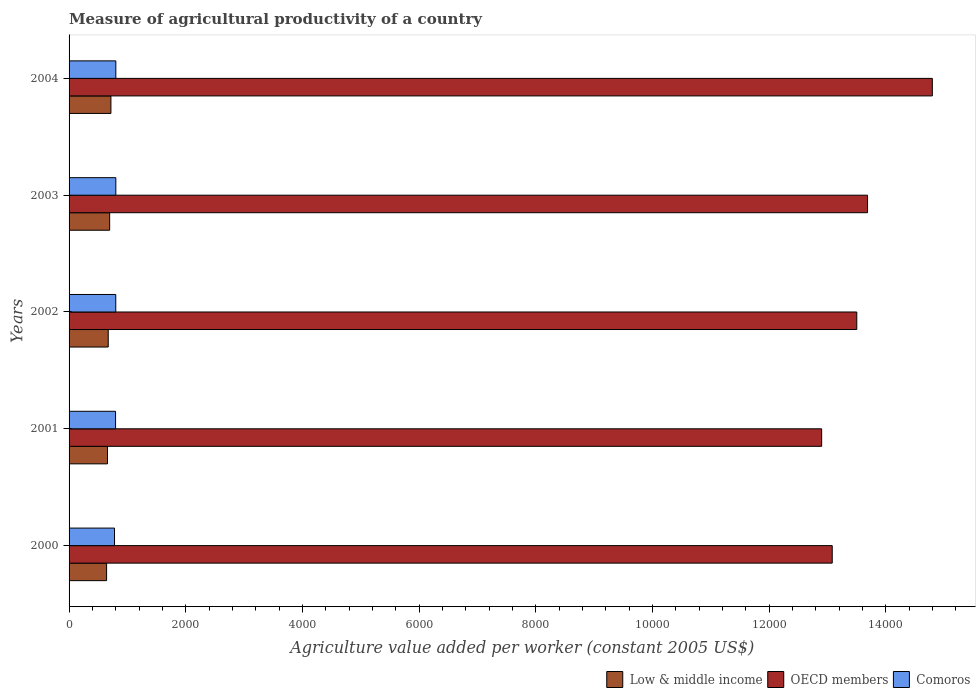How many different coloured bars are there?
Provide a succinct answer. 3. How many groups of bars are there?
Provide a short and direct response. 5. Are the number of bars on each tick of the Y-axis equal?
Keep it short and to the point. Yes. How many bars are there on the 4th tick from the bottom?
Your answer should be very brief. 3. In how many cases, is the number of bars for a given year not equal to the number of legend labels?
Ensure brevity in your answer.  0. What is the measure of agricultural productivity in Low & middle income in 2001?
Provide a short and direct response. 658.75. Across all years, what is the maximum measure of agricultural productivity in Low & middle income?
Offer a terse response. 717.21. Across all years, what is the minimum measure of agricultural productivity in Low & middle income?
Your answer should be very brief. 643.04. What is the total measure of agricultural productivity in Low & middle income in the graph?
Provide a succinct answer. 3385.64. What is the difference between the measure of agricultural productivity in OECD members in 2001 and that in 2004?
Ensure brevity in your answer.  -1896.73. What is the difference between the measure of agricultural productivity in OECD members in 2004 and the measure of agricultural productivity in Low & middle income in 2003?
Provide a short and direct response. 1.41e+04. What is the average measure of agricultural productivity in OECD members per year?
Your answer should be very brief. 1.36e+04. In the year 2000, what is the difference between the measure of agricultural productivity in Low & middle income and measure of agricultural productivity in Comoros?
Provide a short and direct response. -135.79. What is the ratio of the measure of agricultural productivity in Comoros in 2002 to that in 2004?
Provide a short and direct response. 1. Is the difference between the measure of agricultural productivity in Low & middle income in 2000 and 2002 greater than the difference between the measure of agricultural productivity in Comoros in 2000 and 2002?
Your response must be concise. No. What is the difference between the highest and the second highest measure of agricultural productivity in OECD members?
Your answer should be very brief. 1110.25. What is the difference between the highest and the lowest measure of agricultural productivity in Low & middle income?
Your answer should be compact. 74.17. Is the sum of the measure of agricultural productivity in Low & middle income in 2000 and 2004 greater than the maximum measure of agricultural productivity in OECD members across all years?
Your answer should be very brief. No. What does the 1st bar from the top in 2004 represents?
Keep it short and to the point. Comoros. How many bars are there?
Keep it short and to the point. 15. What is the difference between two consecutive major ticks on the X-axis?
Make the answer very short. 2000. Where does the legend appear in the graph?
Offer a terse response. Bottom right. How many legend labels are there?
Your answer should be very brief. 3. How are the legend labels stacked?
Give a very brief answer. Horizontal. What is the title of the graph?
Make the answer very short. Measure of agricultural productivity of a country. Does "Monaco" appear as one of the legend labels in the graph?
Provide a short and direct response. No. What is the label or title of the X-axis?
Your answer should be compact. Agriculture value added per worker (constant 2005 US$). What is the label or title of the Y-axis?
Your response must be concise. Years. What is the Agriculture value added per worker (constant 2005 US$) of Low & middle income in 2000?
Give a very brief answer. 643.04. What is the Agriculture value added per worker (constant 2005 US$) of OECD members in 2000?
Give a very brief answer. 1.31e+04. What is the Agriculture value added per worker (constant 2005 US$) of Comoros in 2000?
Your response must be concise. 778.83. What is the Agriculture value added per worker (constant 2005 US$) in Low & middle income in 2001?
Provide a succinct answer. 658.75. What is the Agriculture value added per worker (constant 2005 US$) of OECD members in 2001?
Your response must be concise. 1.29e+04. What is the Agriculture value added per worker (constant 2005 US$) in Comoros in 2001?
Make the answer very short. 796.84. What is the Agriculture value added per worker (constant 2005 US$) in Low & middle income in 2002?
Keep it short and to the point. 671.12. What is the Agriculture value added per worker (constant 2005 US$) of OECD members in 2002?
Give a very brief answer. 1.35e+04. What is the Agriculture value added per worker (constant 2005 US$) in Comoros in 2002?
Your response must be concise. 800.25. What is the Agriculture value added per worker (constant 2005 US$) of Low & middle income in 2003?
Give a very brief answer. 695.52. What is the Agriculture value added per worker (constant 2005 US$) in OECD members in 2003?
Offer a very short reply. 1.37e+04. What is the Agriculture value added per worker (constant 2005 US$) of Comoros in 2003?
Provide a succinct answer. 801.28. What is the Agriculture value added per worker (constant 2005 US$) in Low & middle income in 2004?
Your answer should be very brief. 717.21. What is the Agriculture value added per worker (constant 2005 US$) of OECD members in 2004?
Offer a very short reply. 1.48e+04. What is the Agriculture value added per worker (constant 2005 US$) of Comoros in 2004?
Ensure brevity in your answer.  801.26. Across all years, what is the maximum Agriculture value added per worker (constant 2005 US$) in Low & middle income?
Provide a short and direct response. 717.21. Across all years, what is the maximum Agriculture value added per worker (constant 2005 US$) in OECD members?
Your response must be concise. 1.48e+04. Across all years, what is the maximum Agriculture value added per worker (constant 2005 US$) in Comoros?
Offer a terse response. 801.28. Across all years, what is the minimum Agriculture value added per worker (constant 2005 US$) of Low & middle income?
Your answer should be very brief. 643.04. Across all years, what is the minimum Agriculture value added per worker (constant 2005 US$) of OECD members?
Your answer should be compact. 1.29e+04. Across all years, what is the minimum Agriculture value added per worker (constant 2005 US$) of Comoros?
Keep it short and to the point. 778.83. What is the total Agriculture value added per worker (constant 2005 US$) of Low & middle income in the graph?
Offer a very short reply. 3385.64. What is the total Agriculture value added per worker (constant 2005 US$) of OECD members in the graph?
Offer a very short reply. 6.80e+04. What is the total Agriculture value added per worker (constant 2005 US$) of Comoros in the graph?
Offer a very short reply. 3978.47. What is the difference between the Agriculture value added per worker (constant 2005 US$) in Low & middle income in 2000 and that in 2001?
Provide a short and direct response. -15.71. What is the difference between the Agriculture value added per worker (constant 2005 US$) in OECD members in 2000 and that in 2001?
Offer a terse response. 181.16. What is the difference between the Agriculture value added per worker (constant 2005 US$) of Comoros in 2000 and that in 2001?
Ensure brevity in your answer.  -18.01. What is the difference between the Agriculture value added per worker (constant 2005 US$) of Low & middle income in 2000 and that in 2002?
Keep it short and to the point. -28.08. What is the difference between the Agriculture value added per worker (constant 2005 US$) of OECD members in 2000 and that in 2002?
Your answer should be very brief. -420.72. What is the difference between the Agriculture value added per worker (constant 2005 US$) of Comoros in 2000 and that in 2002?
Your answer should be compact. -21.42. What is the difference between the Agriculture value added per worker (constant 2005 US$) in Low & middle income in 2000 and that in 2003?
Your answer should be very brief. -52.48. What is the difference between the Agriculture value added per worker (constant 2005 US$) of OECD members in 2000 and that in 2003?
Your response must be concise. -605.32. What is the difference between the Agriculture value added per worker (constant 2005 US$) of Comoros in 2000 and that in 2003?
Provide a short and direct response. -22.45. What is the difference between the Agriculture value added per worker (constant 2005 US$) in Low & middle income in 2000 and that in 2004?
Your answer should be very brief. -74.17. What is the difference between the Agriculture value added per worker (constant 2005 US$) in OECD members in 2000 and that in 2004?
Provide a short and direct response. -1715.56. What is the difference between the Agriculture value added per worker (constant 2005 US$) of Comoros in 2000 and that in 2004?
Provide a short and direct response. -22.43. What is the difference between the Agriculture value added per worker (constant 2005 US$) of Low & middle income in 2001 and that in 2002?
Your answer should be compact. -12.37. What is the difference between the Agriculture value added per worker (constant 2005 US$) in OECD members in 2001 and that in 2002?
Your answer should be very brief. -601.88. What is the difference between the Agriculture value added per worker (constant 2005 US$) in Comoros in 2001 and that in 2002?
Offer a very short reply. -3.41. What is the difference between the Agriculture value added per worker (constant 2005 US$) in Low & middle income in 2001 and that in 2003?
Provide a succinct answer. -36.77. What is the difference between the Agriculture value added per worker (constant 2005 US$) of OECD members in 2001 and that in 2003?
Provide a short and direct response. -786.48. What is the difference between the Agriculture value added per worker (constant 2005 US$) in Comoros in 2001 and that in 2003?
Your response must be concise. -4.44. What is the difference between the Agriculture value added per worker (constant 2005 US$) in Low & middle income in 2001 and that in 2004?
Give a very brief answer. -58.46. What is the difference between the Agriculture value added per worker (constant 2005 US$) of OECD members in 2001 and that in 2004?
Offer a very short reply. -1896.73. What is the difference between the Agriculture value added per worker (constant 2005 US$) of Comoros in 2001 and that in 2004?
Offer a very short reply. -4.42. What is the difference between the Agriculture value added per worker (constant 2005 US$) of Low & middle income in 2002 and that in 2003?
Keep it short and to the point. -24.4. What is the difference between the Agriculture value added per worker (constant 2005 US$) in OECD members in 2002 and that in 2003?
Offer a very short reply. -184.6. What is the difference between the Agriculture value added per worker (constant 2005 US$) of Comoros in 2002 and that in 2003?
Make the answer very short. -1.02. What is the difference between the Agriculture value added per worker (constant 2005 US$) in Low & middle income in 2002 and that in 2004?
Provide a short and direct response. -46.09. What is the difference between the Agriculture value added per worker (constant 2005 US$) of OECD members in 2002 and that in 2004?
Ensure brevity in your answer.  -1294.85. What is the difference between the Agriculture value added per worker (constant 2005 US$) of Comoros in 2002 and that in 2004?
Make the answer very short. -1.01. What is the difference between the Agriculture value added per worker (constant 2005 US$) of Low & middle income in 2003 and that in 2004?
Your response must be concise. -21.69. What is the difference between the Agriculture value added per worker (constant 2005 US$) of OECD members in 2003 and that in 2004?
Your answer should be very brief. -1110.25. What is the difference between the Agriculture value added per worker (constant 2005 US$) in Comoros in 2003 and that in 2004?
Keep it short and to the point. 0.02. What is the difference between the Agriculture value added per worker (constant 2005 US$) of Low & middle income in 2000 and the Agriculture value added per worker (constant 2005 US$) of OECD members in 2001?
Your response must be concise. -1.23e+04. What is the difference between the Agriculture value added per worker (constant 2005 US$) of Low & middle income in 2000 and the Agriculture value added per worker (constant 2005 US$) of Comoros in 2001?
Make the answer very short. -153.81. What is the difference between the Agriculture value added per worker (constant 2005 US$) in OECD members in 2000 and the Agriculture value added per worker (constant 2005 US$) in Comoros in 2001?
Provide a short and direct response. 1.23e+04. What is the difference between the Agriculture value added per worker (constant 2005 US$) in Low & middle income in 2000 and the Agriculture value added per worker (constant 2005 US$) in OECD members in 2002?
Provide a succinct answer. -1.29e+04. What is the difference between the Agriculture value added per worker (constant 2005 US$) of Low & middle income in 2000 and the Agriculture value added per worker (constant 2005 US$) of Comoros in 2002?
Provide a short and direct response. -157.22. What is the difference between the Agriculture value added per worker (constant 2005 US$) of OECD members in 2000 and the Agriculture value added per worker (constant 2005 US$) of Comoros in 2002?
Your answer should be compact. 1.23e+04. What is the difference between the Agriculture value added per worker (constant 2005 US$) of Low & middle income in 2000 and the Agriculture value added per worker (constant 2005 US$) of OECD members in 2003?
Keep it short and to the point. -1.30e+04. What is the difference between the Agriculture value added per worker (constant 2005 US$) of Low & middle income in 2000 and the Agriculture value added per worker (constant 2005 US$) of Comoros in 2003?
Provide a succinct answer. -158.24. What is the difference between the Agriculture value added per worker (constant 2005 US$) in OECD members in 2000 and the Agriculture value added per worker (constant 2005 US$) in Comoros in 2003?
Offer a terse response. 1.23e+04. What is the difference between the Agriculture value added per worker (constant 2005 US$) in Low & middle income in 2000 and the Agriculture value added per worker (constant 2005 US$) in OECD members in 2004?
Ensure brevity in your answer.  -1.42e+04. What is the difference between the Agriculture value added per worker (constant 2005 US$) of Low & middle income in 2000 and the Agriculture value added per worker (constant 2005 US$) of Comoros in 2004?
Ensure brevity in your answer.  -158.23. What is the difference between the Agriculture value added per worker (constant 2005 US$) of OECD members in 2000 and the Agriculture value added per worker (constant 2005 US$) of Comoros in 2004?
Your answer should be very brief. 1.23e+04. What is the difference between the Agriculture value added per worker (constant 2005 US$) in Low & middle income in 2001 and the Agriculture value added per worker (constant 2005 US$) in OECD members in 2002?
Keep it short and to the point. -1.28e+04. What is the difference between the Agriculture value added per worker (constant 2005 US$) in Low & middle income in 2001 and the Agriculture value added per worker (constant 2005 US$) in Comoros in 2002?
Offer a terse response. -141.5. What is the difference between the Agriculture value added per worker (constant 2005 US$) in OECD members in 2001 and the Agriculture value added per worker (constant 2005 US$) in Comoros in 2002?
Your answer should be very brief. 1.21e+04. What is the difference between the Agriculture value added per worker (constant 2005 US$) in Low & middle income in 2001 and the Agriculture value added per worker (constant 2005 US$) in OECD members in 2003?
Keep it short and to the point. -1.30e+04. What is the difference between the Agriculture value added per worker (constant 2005 US$) of Low & middle income in 2001 and the Agriculture value added per worker (constant 2005 US$) of Comoros in 2003?
Give a very brief answer. -142.53. What is the difference between the Agriculture value added per worker (constant 2005 US$) of OECD members in 2001 and the Agriculture value added per worker (constant 2005 US$) of Comoros in 2003?
Provide a succinct answer. 1.21e+04. What is the difference between the Agriculture value added per worker (constant 2005 US$) of Low & middle income in 2001 and the Agriculture value added per worker (constant 2005 US$) of OECD members in 2004?
Make the answer very short. -1.41e+04. What is the difference between the Agriculture value added per worker (constant 2005 US$) of Low & middle income in 2001 and the Agriculture value added per worker (constant 2005 US$) of Comoros in 2004?
Provide a short and direct response. -142.51. What is the difference between the Agriculture value added per worker (constant 2005 US$) in OECD members in 2001 and the Agriculture value added per worker (constant 2005 US$) in Comoros in 2004?
Provide a short and direct response. 1.21e+04. What is the difference between the Agriculture value added per worker (constant 2005 US$) of Low & middle income in 2002 and the Agriculture value added per worker (constant 2005 US$) of OECD members in 2003?
Provide a short and direct response. -1.30e+04. What is the difference between the Agriculture value added per worker (constant 2005 US$) in Low & middle income in 2002 and the Agriculture value added per worker (constant 2005 US$) in Comoros in 2003?
Provide a succinct answer. -130.16. What is the difference between the Agriculture value added per worker (constant 2005 US$) in OECD members in 2002 and the Agriculture value added per worker (constant 2005 US$) in Comoros in 2003?
Provide a short and direct response. 1.27e+04. What is the difference between the Agriculture value added per worker (constant 2005 US$) of Low & middle income in 2002 and the Agriculture value added per worker (constant 2005 US$) of OECD members in 2004?
Keep it short and to the point. -1.41e+04. What is the difference between the Agriculture value added per worker (constant 2005 US$) of Low & middle income in 2002 and the Agriculture value added per worker (constant 2005 US$) of Comoros in 2004?
Make the answer very short. -130.14. What is the difference between the Agriculture value added per worker (constant 2005 US$) in OECD members in 2002 and the Agriculture value added per worker (constant 2005 US$) in Comoros in 2004?
Provide a short and direct response. 1.27e+04. What is the difference between the Agriculture value added per worker (constant 2005 US$) in Low & middle income in 2003 and the Agriculture value added per worker (constant 2005 US$) in OECD members in 2004?
Ensure brevity in your answer.  -1.41e+04. What is the difference between the Agriculture value added per worker (constant 2005 US$) of Low & middle income in 2003 and the Agriculture value added per worker (constant 2005 US$) of Comoros in 2004?
Ensure brevity in your answer.  -105.74. What is the difference between the Agriculture value added per worker (constant 2005 US$) of OECD members in 2003 and the Agriculture value added per worker (constant 2005 US$) of Comoros in 2004?
Make the answer very short. 1.29e+04. What is the average Agriculture value added per worker (constant 2005 US$) in Low & middle income per year?
Provide a succinct answer. 677.13. What is the average Agriculture value added per worker (constant 2005 US$) in OECD members per year?
Provide a succinct answer. 1.36e+04. What is the average Agriculture value added per worker (constant 2005 US$) in Comoros per year?
Your response must be concise. 795.69. In the year 2000, what is the difference between the Agriculture value added per worker (constant 2005 US$) in Low & middle income and Agriculture value added per worker (constant 2005 US$) in OECD members?
Your answer should be very brief. -1.24e+04. In the year 2000, what is the difference between the Agriculture value added per worker (constant 2005 US$) of Low & middle income and Agriculture value added per worker (constant 2005 US$) of Comoros?
Provide a succinct answer. -135.79. In the year 2000, what is the difference between the Agriculture value added per worker (constant 2005 US$) in OECD members and Agriculture value added per worker (constant 2005 US$) in Comoros?
Provide a short and direct response. 1.23e+04. In the year 2001, what is the difference between the Agriculture value added per worker (constant 2005 US$) of Low & middle income and Agriculture value added per worker (constant 2005 US$) of OECD members?
Ensure brevity in your answer.  -1.22e+04. In the year 2001, what is the difference between the Agriculture value added per worker (constant 2005 US$) of Low & middle income and Agriculture value added per worker (constant 2005 US$) of Comoros?
Give a very brief answer. -138.09. In the year 2001, what is the difference between the Agriculture value added per worker (constant 2005 US$) of OECD members and Agriculture value added per worker (constant 2005 US$) of Comoros?
Your answer should be compact. 1.21e+04. In the year 2002, what is the difference between the Agriculture value added per worker (constant 2005 US$) of Low & middle income and Agriculture value added per worker (constant 2005 US$) of OECD members?
Your answer should be very brief. -1.28e+04. In the year 2002, what is the difference between the Agriculture value added per worker (constant 2005 US$) in Low & middle income and Agriculture value added per worker (constant 2005 US$) in Comoros?
Offer a terse response. -129.13. In the year 2002, what is the difference between the Agriculture value added per worker (constant 2005 US$) of OECD members and Agriculture value added per worker (constant 2005 US$) of Comoros?
Offer a terse response. 1.27e+04. In the year 2003, what is the difference between the Agriculture value added per worker (constant 2005 US$) of Low & middle income and Agriculture value added per worker (constant 2005 US$) of OECD members?
Provide a short and direct response. -1.30e+04. In the year 2003, what is the difference between the Agriculture value added per worker (constant 2005 US$) in Low & middle income and Agriculture value added per worker (constant 2005 US$) in Comoros?
Give a very brief answer. -105.76. In the year 2003, what is the difference between the Agriculture value added per worker (constant 2005 US$) of OECD members and Agriculture value added per worker (constant 2005 US$) of Comoros?
Keep it short and to the point. 1.29e+04. In the year 2004, what is the difference between the Agriculture value added per worker (constant 2005 US$) in Low & middle income and Agriculture value added per worker (constant 2005 US$) in OECD members?
Make the answer very short. -1.41e+04. In the year 2004, what is the difference between the Agriculture value added per worker (constant 2005 US$) in Low & middle income and Agriculture value added per worker (constant 2005 US$) in Comoros?
Make the answer very short. -84.05. In the year 2004, what is the difference between the Agriculture value added per worker (constant 2005 US$) of OECD members and Agriculture value added per worker (constant 2005 US$) of Comoros?
Offer a terse response. 1.40e+04. What is the ratio of the Agriculture value added per worker (constant 2005 US$) in Low & middle income in 2000 to that in 2001?
Provide a short and direct response. 0.98. What is the ratio of the Agriculture value added per worker (constant 2005 US$) in OECD members in 2000 to that in 2001?
Provide a short and direct response. 1.01. What is the ratio of the Agriculture value added per worker (constant 2005 US$) in Comoros in 2000 to that in 2001?
Your response must be concise. 0.98. What is the ratio of the Agriculture value added per worker (constant 2005 US$) of Low & middle income in 2000 to that in 2002?
Ensure brevity in your answer.  0.96. What is the ratio of the Agriculture value added per worker (constant 2005 US$) of OECD members in 2000 to that in 2002?
Give a very brief answer. 0.97. What is the ratio of the Agriculture value added per worker (constant 2005 US$) of Comoros in 2000 to that in 2002?
Make the answer very short. 0.97. What is the ratio of the Agriculture value added per worker (constant 2005 US$) of Low & middle income in 2000 to that in 2003?
Your answer should be very brief. 0.92. What is the ratio of the Agriculture value added per worker (constant 2005 US$) in OECD members in 2000 to that in 2003?
Give a very brief answer. 0.96. What is the ratio of the Agriculture value added per worker (constant 2005 US$) in Low & middle income in 2000 to that in 2004?
Give a very brief answer. 0.9. What is the ratio of the Agriculture value added per worker (constant 2005 US$) in OECD members in 2000 to that in 2004?
Offer a very short reply. 0.88. What is the ratio of the Agriculture value added per worker (constant 2005 US$) of Low & middle income in 2001 to that in 2002?
Provide a succinct answer. 0.98. What is the ratio of the Agriculture value added per worker (constant 2005 US$) in OECD members in 2001 to that in 2002?
Keep it short and to the point. 0.96. What is the ratio of the Agriculture value added per worker (constant 2005 US$) of Comoros in 2001 to that in 2002?
Keep it short and to the point. 1. What is the ratio of the Agriculture value added per worker (constant 2005 US$) of Low & middle income in 2001 to that in 2003?
Provide a succinct answer. 0.95. What is the ratio of the Agriculture value added per worker (constant 2005 US$) of OECD members in 2001 to that in 2003?
Keep it short and to the point. 0.94. What is the ratio of the Agriculture value added per worker (constant 2005 US$) of Comoros in 2001 to that in 2003?
Offer a very short reply. 0.99. What is the ratio of the Agriculture value added per worker (constant 2005 US$) of Low & middle income in 2001 to that in 2004?
Your response must be concise. 0.92. What is the ratio of the Agriculture value added per worker (constant 2005 US$) in OECD members in 2001 to that in 2004?
Make the answer very short. 0.87. What is the ratio of the Agriculture value added per worker (constant 2005 US$) of Comoros in 2001 to that in 2004?
Your answer should be compact. 0.99. What is the ratio of the Agriculture value added per worker (constant 2005 US$) of Low & middle income in 2002 to that in 2003?
Your answer should be compact. 0.96. What is the ratio of the Agriculture value added per worker (constant 2005 US$) of OECD members in 2002 to that in 2003?
Your answer should be very brief. 0.99. What is the ratio of the Agriculture value added per worker (constant 2005 US$) of Comoros in 2002 to that in 2003?
Offer a terse response. 1. What is the ratio of the Agriculture value added per worker (constant 2005 US$) in Low & middle income in 2002 to that in 2004?
Your answer should be very brief. 0.94. What is the ratio of the Agriculture value added per worker (constant 2005 US$) in OECD members in 2002 to that in 2004?
Ensure brevity in your answer.  0.91. What is the ratio of the Agriculture value added per worker (constant 2005 US$) in Comoros in 2002 to that in 2004?
Your response must be concise. 1. What is the ratio of the Agriculture value added per worker (constant 2005 US$) in Low & middle income in 2003 to that in 2004?
Keep it short and to the point. 0.97. What is the ratio of the Agriculture value added per worker (constant 2005 US$) of OECD members in 2003 to that in 2004?
Ensure brevity in your answer.  0.93. What is the ratio of the Agriculture value added per worker (constant 2005 US$) of Comoros in 2003 to that in 2004?
Ensure brevity in your answer.  1. What is the difference between the highest and the second highest Agriculture value added per worker (constant 2005 US$) in Low & middle income?
Offer a terse response. 21.69. What is the difference between the highest and the second highest Agriculture value added per worker (constant 2005 US$) in OECD members?
Your answer should be compact. 1110.25. What is the difference between the highest and the second highest Agriculture value added per worker (constant 2005 US$) in Comoros?
Ensure brevity in your answer.  0.02. What is the difference between the highest and the lowest Agriculture value added per worker (constant 2005 US$) in Low & middle income?
Your answer should be very brief. 74.17. What is the difference between the highest and the lowest Agriculture value added per worker (constant 2005 US$) of OECD members?
Give a very brief answer. 1896.73. What is the difference between the highest and the lowest Agriculture value added per worker (constant 2005 US$) of Comoros?
Offer a very short reply. 22.45. 